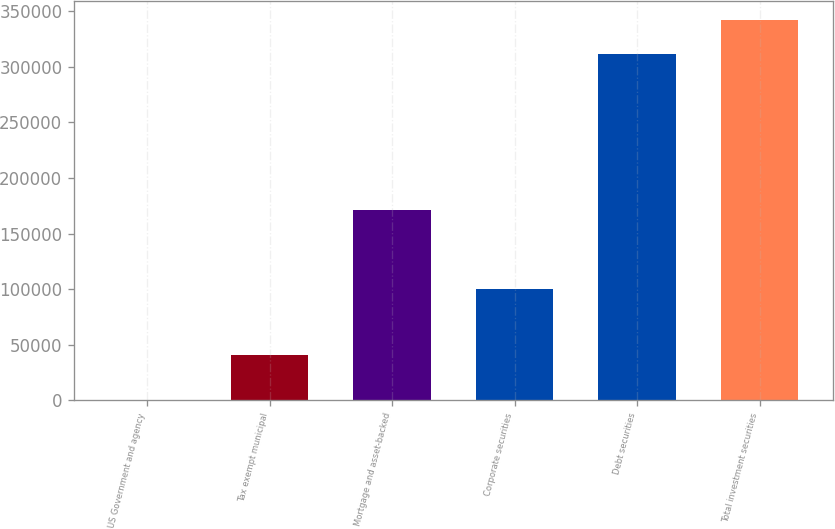<chart> <loc_0><loc_0><loc_500><loc_500><bar_chart><fcel>US Government and agency<fcel>Tax exempt municipal<fcel>Mortgage and asset-backed<fcel>Corporate securities<fcel>Debt securities<fcel>Total investment securities<nl><fcel>285<fcel>40213<fcel>171041<fcel>99842<fcel>311381<fcel>342656<nl></chart> 